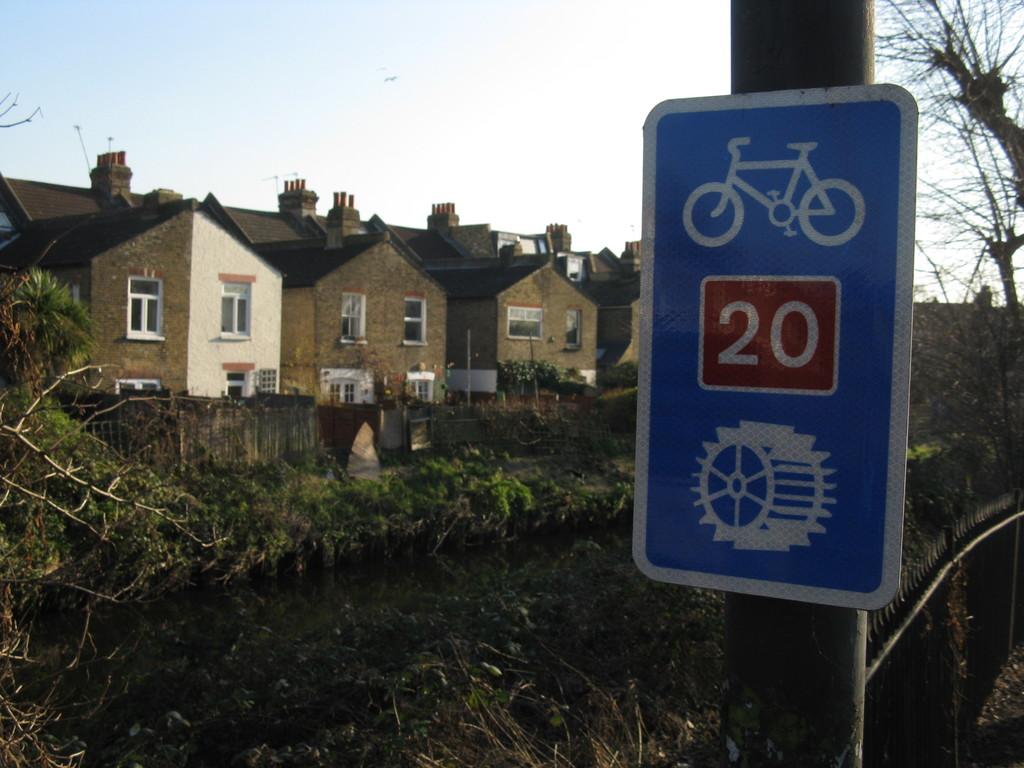What number is shown?
Offer a very short reply. 20. 